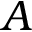<formula> <loc_0><loc_0><loc_500><loc_500>A</formula> 